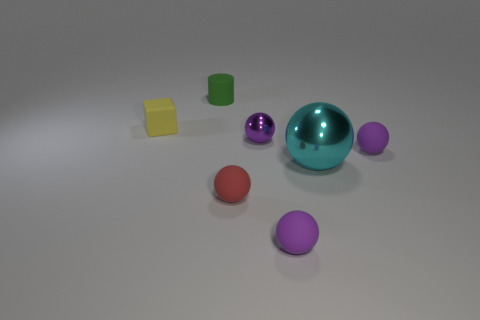Subtract all red balls. How many balls are left? 4 Subtract all cyan metal spheres. How many spheres are left? 4 Subtract all purple matte things. Subtract all yellow things. How many objects are left? 4 Add 1 purple metallic things. How many purple metallic things are left? 2 Add 1 small red rubber cubes. How many small red rubber cubes exist? 1 Add 1 red matte spheres. How many objects exist? 8 Subtract 0 gray spheres. How many objects are left? 7 Subtract all cylinders. How many objects are left? 6 Subtract 4 balls. How many balls are left? 1 Subtract all purple balls. Subtract all blue blocks. How many balls are left? 2 